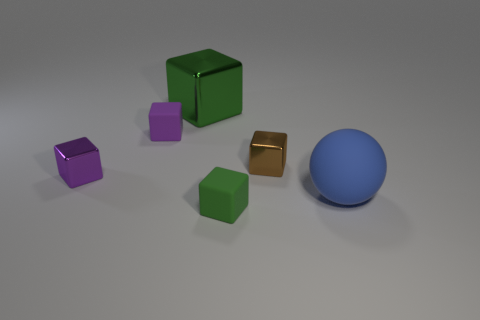Is there a green object that has the same size as the brown object?
Provide a succinct answer. Yes. Are there fewer tiny matte blocks that are behind the purple matte block than big red rubber blocks?
Your answer should be very brief. No. Is the number of big spheres on the left side of the tiny brown metallic block less than the number of purple objects to the right of the purple metal block?
Offer a terse response. Yes. What number of blocks are small matte things or brown things?
Provide a short and direct response. 3. Are the big object in front of the big block and the green object that is in front of the big blue rubber thing made of the same material?
Offer a very short reply. Yes. There is a purple shiny object that is the same size as the brown metallic thing; what is its shape?
Keep it short and to the point. Cube. What number of other objects are there of the same color as the large block?
Your response must be concise. 1. What number of green things are either big shiny things or matte cubes?
Give a very brief answer. 2. Does the big object that is in front of the big cube have the same shape as the thing behind the tiny purple rubber object?
Provide a short and direct response. No. What number of other objects are the same material as the large cube?
Make the answer very short. 2. 